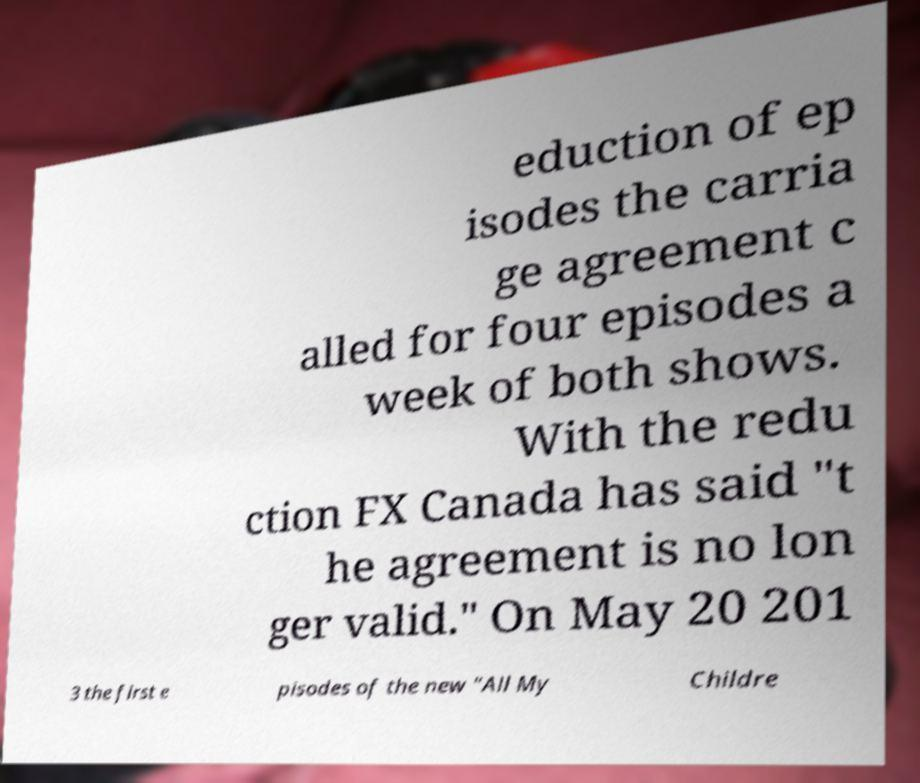Could you assist in decoding the text presented in this image and type it out clearly? eduction of ep isodes the carria ge agreement c alled for four episodes a week of both shows. With the redu ction FX Canada has said "t he agreement is no lon ger valid." On May 20 201 3 the first e pisodes of the new "All My Childre 